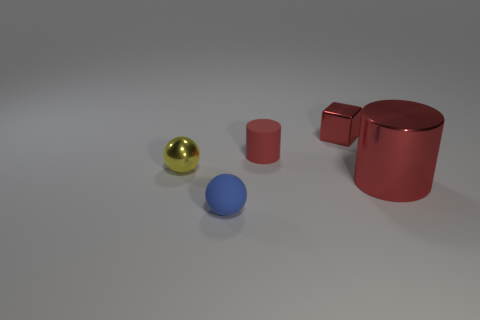Add 2 small blue balls. How many objects exist? 7 Subtract all cylinders. How many objects are left? 3 Subtract all red metal cubes. Subtract all blocks. How many objects are left? 3 Add 2 matte cylinders. How many matte cylinders are left? 3 Add 4 small red matte objects. How many small red matte objects exist? 5 Subtract 0 brown cylinders. How many objects are left? 5 